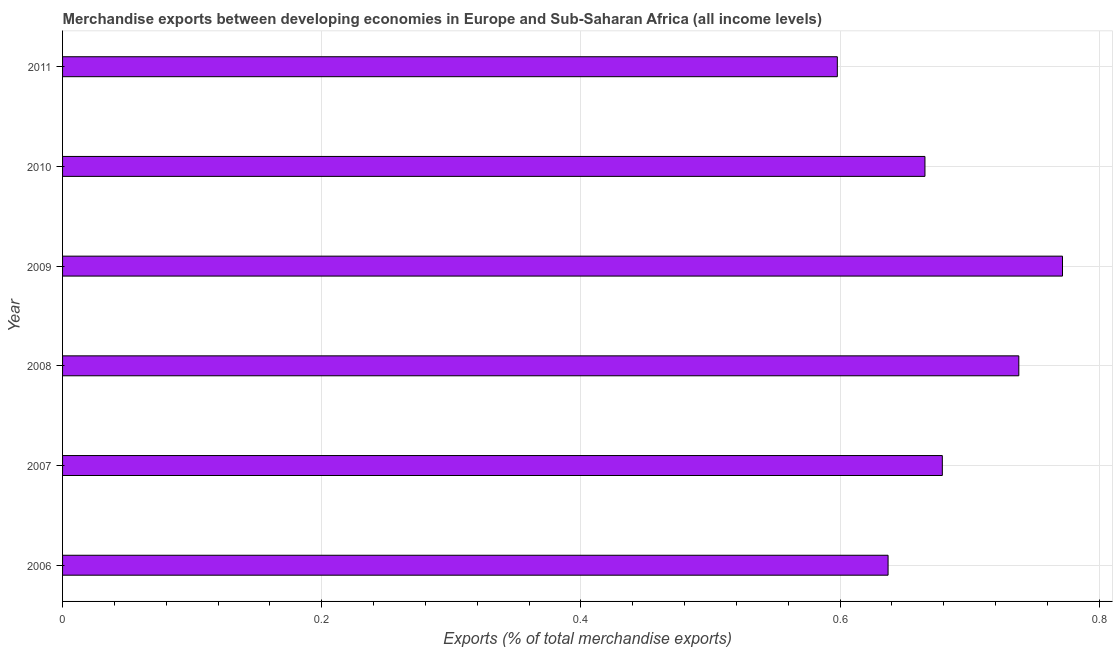Does the graph contain grids?
Provide a succinct answer. Yes. What is the title of the graph?
Your answer should be compact. Merchandise exports between developing economies in Europe and Sub-Saharan Africa (all income levels). What is the label or title of the X-axis?
Provide a succinct answer. Exports (% of total merchandise exports). What is the merchandise exports in 2009?
Keep it short and to the point. 0.77. Across all years, what is the maximum merchandise exports?
Your response must be concise. 0.77. Across all years, what is the minimum merchandise exports?
Your response must be concise. 0.6. In which year was the merchandise exports minimum?
Provide a succinct answer. 2011. What is the sum of the merchandise exports?
Provide a short and direct response. 4.09. What is the difference between the merchandise exports in 2007 and 2010?
Your answer should be compact. 0.01. What is the average merchandise exports per year?
Your answer should be very brief. 0.68. What is the median merchandise exports?
Make the answer very short. 0.67. Do a majority of the years between 2008 and 2010 (inclusive) have merchandise exports greater than 0.28 %?
Keep it short and to the point. Yes. What is the ratio of the merchandise exports in 2009 to that in 2010?
Provide a succinct answer. 1.16. Is the difference between the merchandise exports in 2010 and 2011 greater than the difference between any two years?
Make the answer very short. No. What is the difference between the highest and the second highest merchandise exports?
Ensure brevity in your answer.  0.03. What is the difference between the highest and the lowest merchandise exports?
Your response must be concise. 0.17. In how many years, is the merchandise exports greater than the average merchandise exports taken over all years?
Ensure brevity in your answer.  2. How many bars are there?
Give a very brief answer. 6. What is the difference between two consecutive major ticks on the X-axis?
Provide a succinct answer. 0.2. Are the values on the major ticks of X-axis written in scientific E-notation?
Offer a terse response. No. What is the Exports (% of total merchandise exports) of 2006?
Offer a terse response. 0.64. What is the Exports (% of total merchandise exports) of 2007?
Your answer should be compact. 0.68. What is the Exports (% of total merchandise exports) in 2008?
Ensure brevity in your answer.  0.74. What is the Exports (% of total merchandise exports) of 2009?
Your answer should be very brief. 0.77. What is the Exports (% of total merchandise exports) in 2010?
Give a very brief answer. 0.67. What is the Exports (% of total merchandise exports) in 2011?
Provide a short and direct response. 0.6. What is the difference between the Exports (% of total merchandise exports) in 2006 and 2007?
Offer a terse response. -0.04. What is the difference between the Exports (% of total merchandise exports) in 2006 and 2008?
Your response must be concise. -0.1. What is the difference between the Exports (% of total merchandise exports) in 2006 and 2009?
Your answer should be very brief. -0.13. What is the difference between the Exports (% of total merchandise exports) in 2006 and 2010?
Make the answer very short. -0.03. What is the difference between the Exports (% of total merchandise exports) in 2006 and 2011?
Provide a succinct answer. 0.04. What is the difference between the Exports (% of total merchandise exports) in 2007 and 2008?
Ensure brevity in your answer.  -0.06. What is the difference between the Exports (% of total merchandise exports) in 2007 and 2009?
Your response must be concise. -0.09. What is the difference between the Exports (% of total merchandise exports) in 2007 and 2010?
Offer a terse response. 0.01. What is the difference between the Exports (% of total merchandise exports) in 2007 and 2011?
Give a very brief answer. 0.08. What is the difference between the Exports (% of total merchandise exports) in 2008 and 2009?
Your answer should be compact. -0.03. What is the difference between the Exports (% of total merchandise exports) in 2008 and 2010?
Your response must be concise. 0.07. What is the difference between the Exports (% of total merchandise exports) in 2008 and 2011?
Your answer should be compact. 0.14. What is the difference between the Exports (% of total merchandise exports) in 2009 and 2010?
Provide a short and direct response. 0.11. What is the difference between the Exports (% of total merchandise exports) in 2009 and 2011?
Keep it short and to the point. 0.17. What is the difference between the Exports (% of total merchandise exports) in 2010 and 2011?
Offer a terse response. 0.07. What is the ratio of the Exports (% of total merchandise exports) in 2006 to that in 2007?
Provide a succinct answer. 0.94. What is the ratio of the Exports (% of total merchandise exports) in 2006 to that in 2008?
Your response must be concise. 0.86. What is the ratio of the Exports (% of total merchandise exports) in 2006 to that in 2009?
Your response must be concise. 0.83. What is the ratio of the Exports (% of total merchandise exports) in 2006 to that in 2010?
Give a very brief answer. 0.96. What is the ratio of the Exports (% of total merchandise exports) in 2006 to that in 2011?
Keep it short and to the point. 1.06. What is the ratio of the Exports (% of total merchandise exports) in 2007 to that in 2011?
Provide a succinct answer. 1.14. What is the ratio of the Exports (% of total merchandise exports) in 2008 to that in 2009?
Offer a very short reply. 0.96. What is the ratio of the Exports (% of total merchandise exports) in 2008 to that in 2010?
Provide a short and direct response. 1.11. What is the ratio of the Exports (% of total merchandise exports) in 2008 to that in 2011?
Offer a very short reply. 1.23. What is the ratio of the Exports (% of total merchandise exports) in 2009 to that in 2010?
Make the answer very short. 1.16. What is the ratio of the Exports (% of total merchandise exports) in 2009 to that in 2011?
Your answer should be compact. 1.29. What is the ratio of the Exports (% of total merchandise exports) in 2010 to that in 2011?
Offer a terse response. 1.11. 